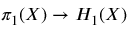Convert formula to latex. <formula><loc_0><loc_0><loc_500><loc_500>\pi _ { 1 } ( X ) \to H _ { 1 } ( X )</formula> 